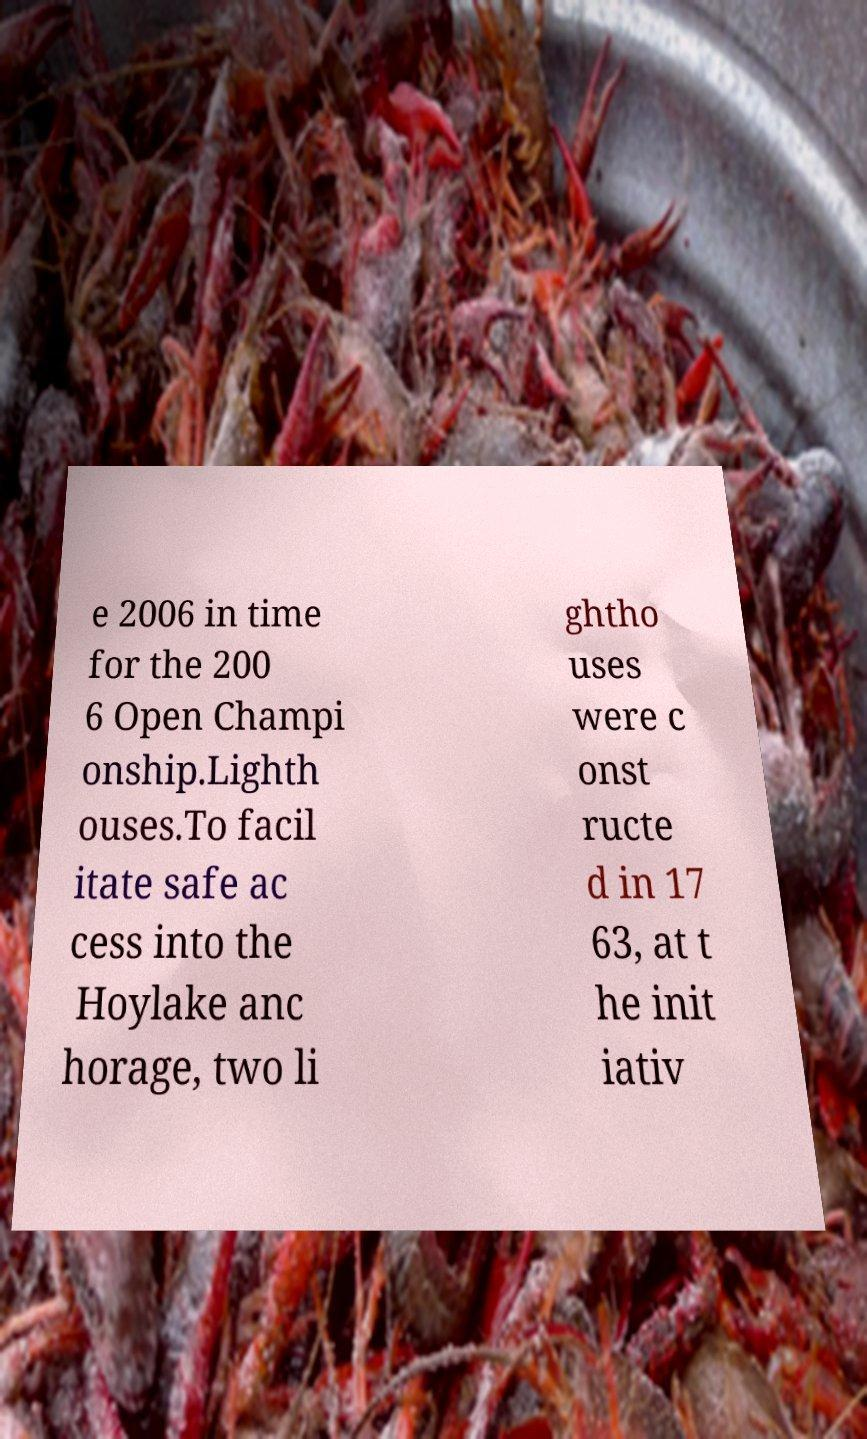What messages or text are displayed in this image? I need them in a readable, typed format. e 2006 in time for the 200 6 Open Champi onship.Lighth ouses.To facil itate safe ac cess into the Hoylake anc horage, two li ghtho uses were c onst ructe d in 17 63, at t he init iativ 